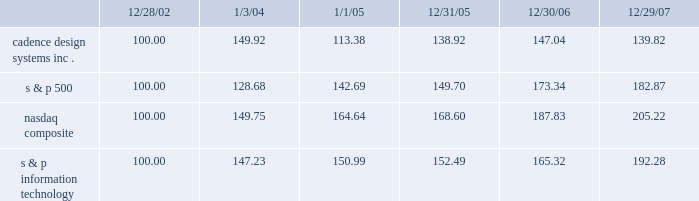The graph below matches cadence design systems , inc . 2019s cumulative 5-year total shareholder return on common stock with the cumulative total returns of the s&p 500 index , the s&p information technology index , and the nasdaq composite index .
The graph assumes that the value of the investment in our common stock , and in each index ( including reinvestment of dividends ) was $ 100 on december 28 , 2002 and tracks it through december 29 , 2007 .
Comparison of 5 year cumulative total return* among cadence design systems , inc. , the s&p 500 index , the nasdaq composite index and the s&p information technology index 12/29/0712/30/0612/31/051/1/051/3/0412/28/02 cadence design systems , inc .
Nasdaq composite s & p information technology s & p 500 * $ 100 invested on 12/28/02 in stock or on 12/31/02 in index-including reinvestment of dividends .
Indexes calculated on month-end basis .
Copyright b7 2007 , standard & poor 2019s , a division of the mcgraw-hill companies , inc .
All rights reserved .
Www.researchdatagroup.com/s&p.htm .
The stock price performance included in this graph is not necessarily indicative of future stock price performance .
What was the difference in percentage cadence design systems , inc . 2019s cumulative 5-year total shareholder return on common stock versus the s&p 500 for the period ending 12/29/07? 
Computations: (((139.82 - 100) / 100) - ((182.87 - 100) / 100))
Answer: -0.4305. 